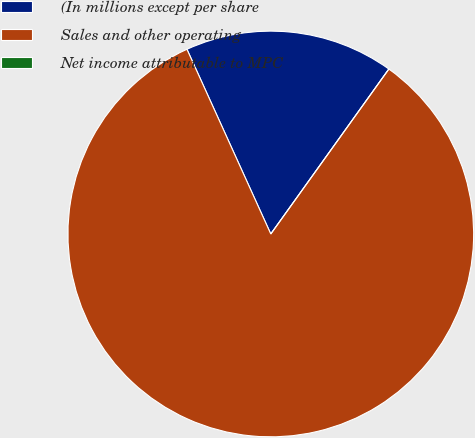Convert chart to OTSL. <chart><loc_0><loc_0><loc_500><loc_500><pie_chart><fcel>(In millions except per share<fcel>Sales and other operating<fcel>Net income attributable to MPC<nl><fcel>16.67%<fcel>83.33%<fcel>0.0%<nl></chart> 